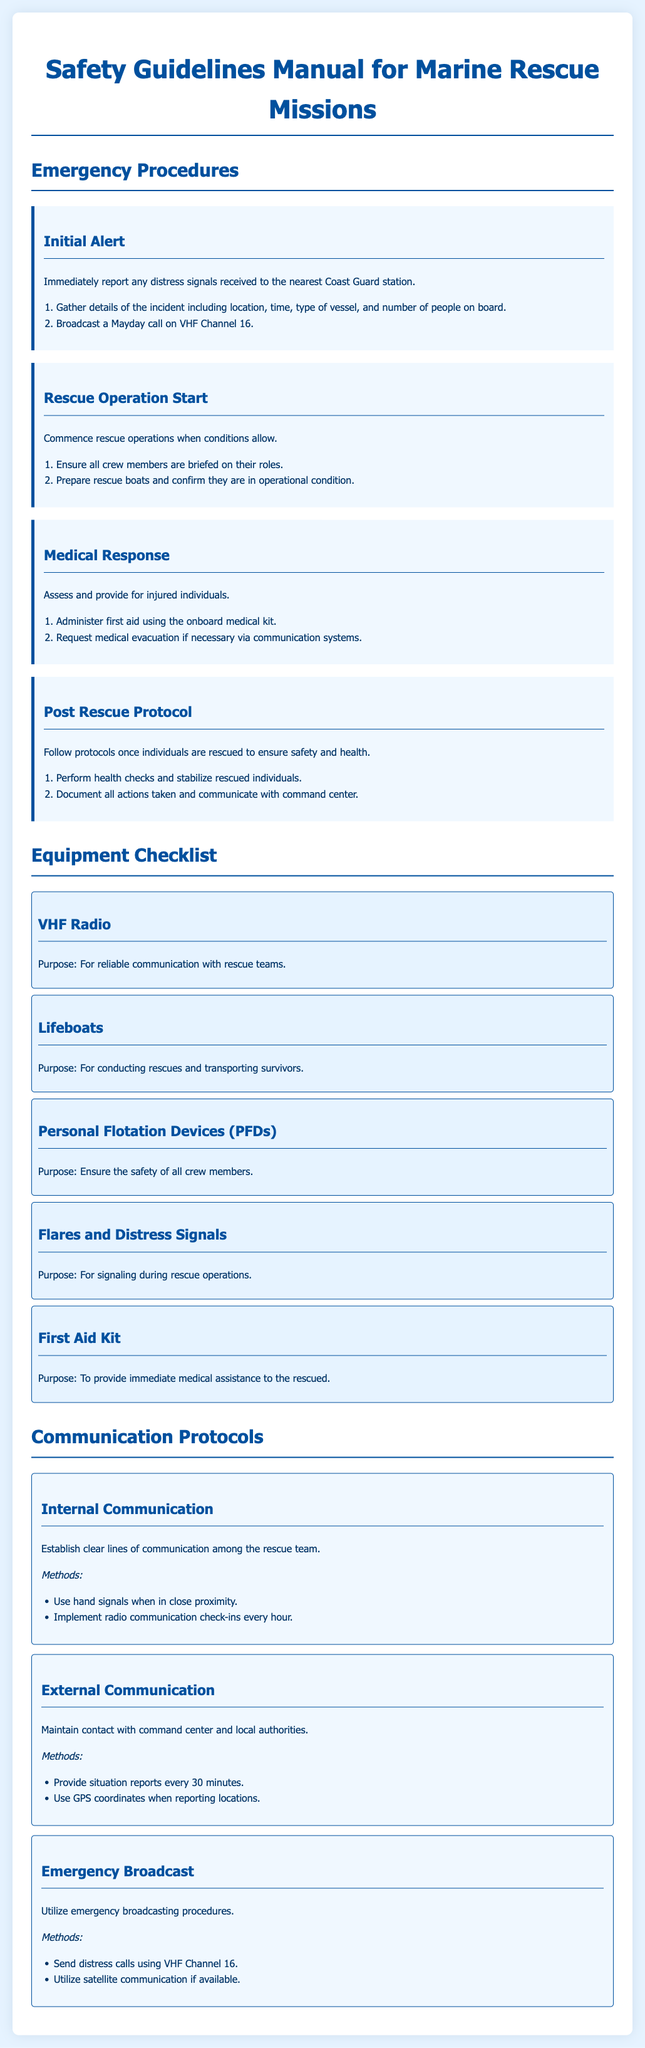What is the first step in the emergency procedures? The first step involves reporting any distress signals to the nearest Coast Guard station.
Answer: report distress signals What is the purpose of Personal Flotation Devices? The purpose is to ensure the safety of all crew members during rescue missions.
Answer: ensure safety How often should internal radio communication check-ins occur? The document specifies that radio communication check-ins should happen every hour.
Answer: every hour What medical equipment should be used to assist injured individuals? The onboard medical kit should be used to administer first aid.
Answer: medical kit What should be documented post-rescue? All actions taken during the rescue should be documented and communicated to the command center.
Answer: document actions taken How should distress calls be sent? Distress calls should be sent using VHF Channel 16 according to the emergency broadcast protocols.
Answer: VHF Channel 16 What is one piece of equipment included in the Equipment Checklist? Flares and distress signals are listed as part of the equipment checklist for signaling during rescue operations.
Answer: Flares and distress signals What is the purpose of the First Aid Kit? The purpose of the First Aid Kit is to provide immediate medical assistance to the rescued individuals.
Answer: immediate medical assistance What should be performed once individuals are rescued? Health checks should be performed to stabilize rescued individuals after their rescue.
Answer: health checks 